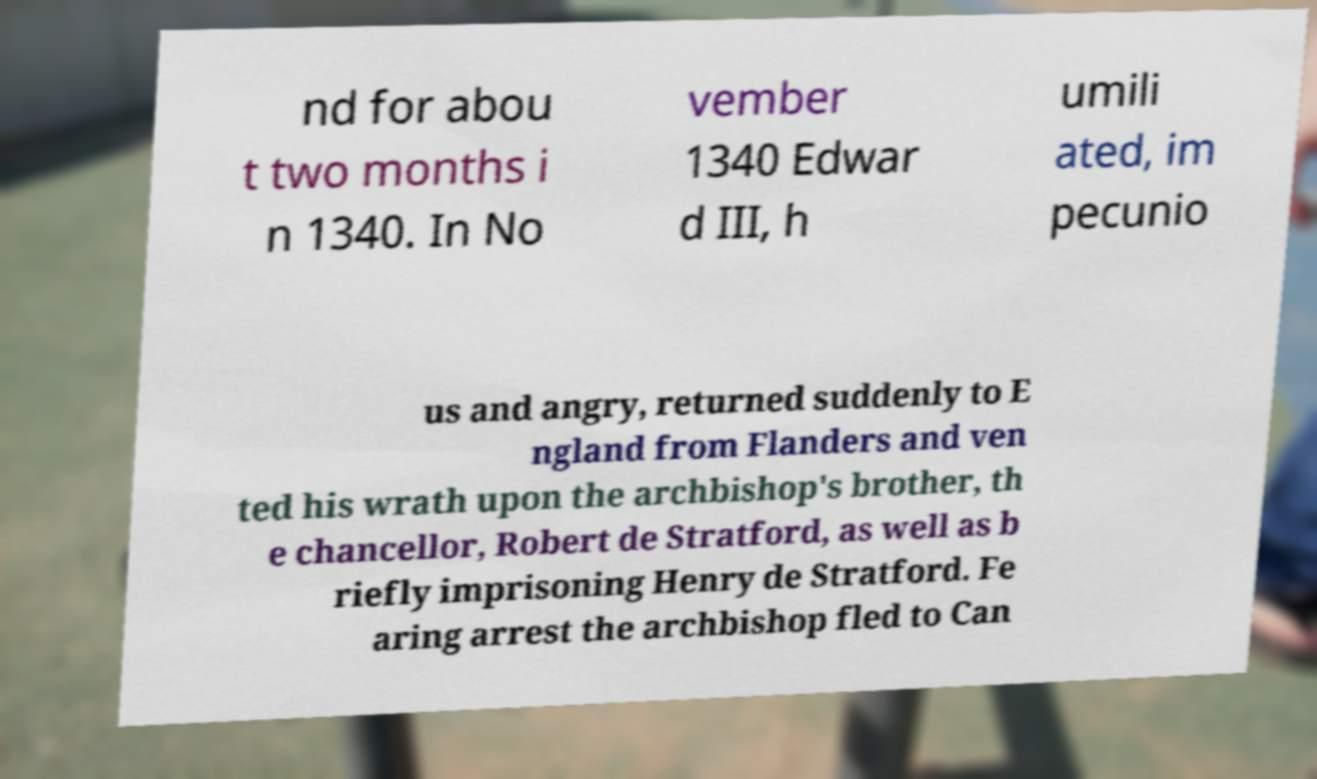Could you extract and type out the text from this image? nd for abou t two months i n 1340. In No vember 1340 Edwar d III, h umili ated, im pecunio us and angry, returned suddenly to E ngland from Flanders and ven ted his wrath upon the archbishop's brother, th e chancellor, Robert de Stratford, as well as b riefly imprisoning Henry de Stratford. Fe aring arrest the archbishop fled to Can 